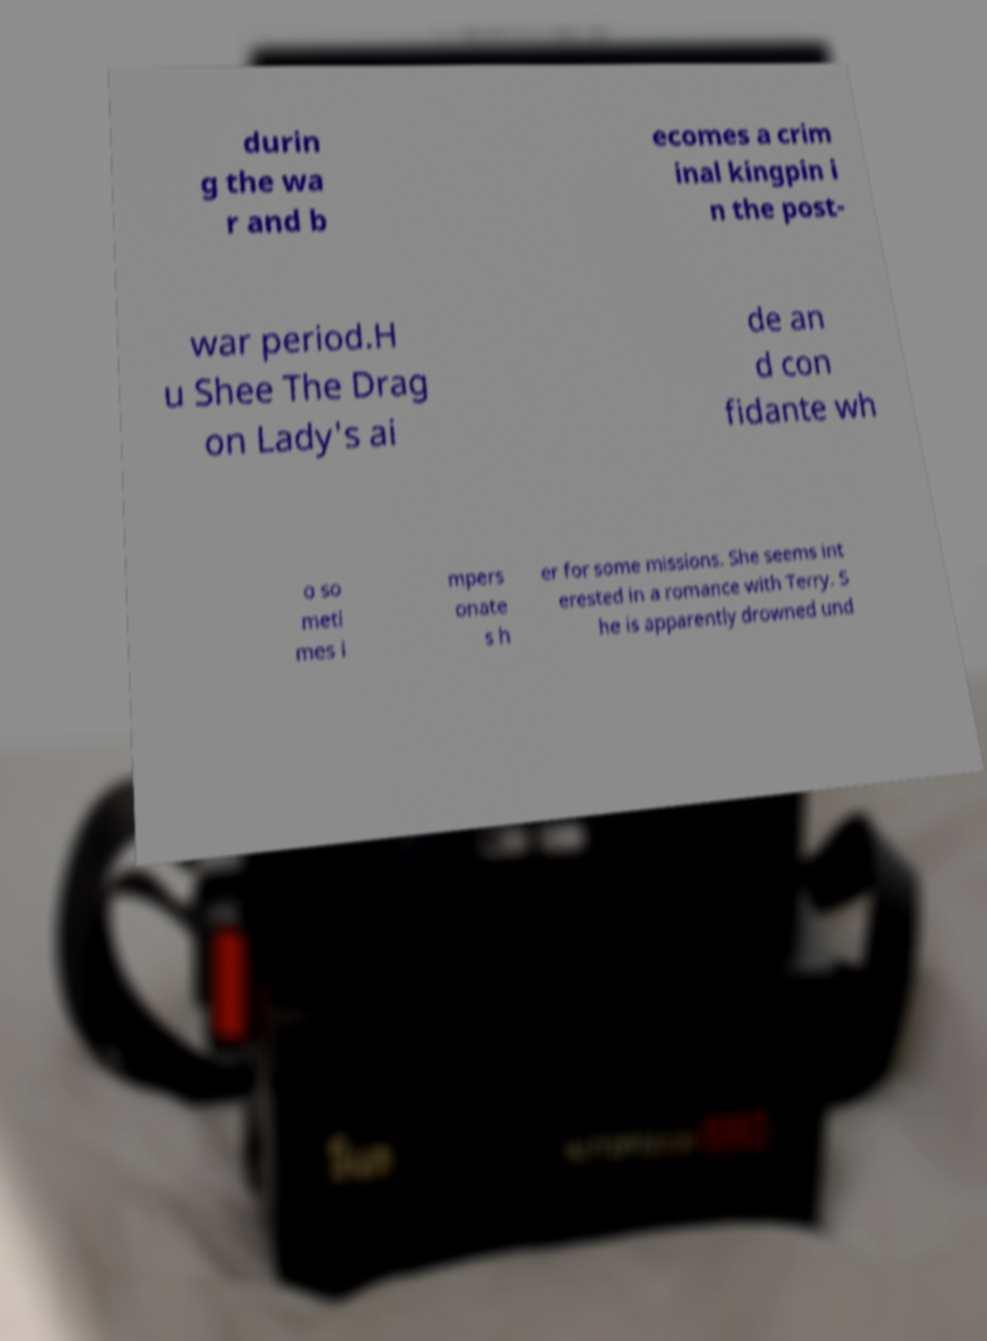What messages or text are displayed in this image? I need them in a readable, typed format. durin g the wa r and b ecomes a crim inal kingpin i n the post- war period.H u Shee The Drag on Lady's ai de an d con fidante wh o so meti mes i mpers onate s h er for some missions. She seems int erested in a romance with Terry. S he is apparently drowned und 